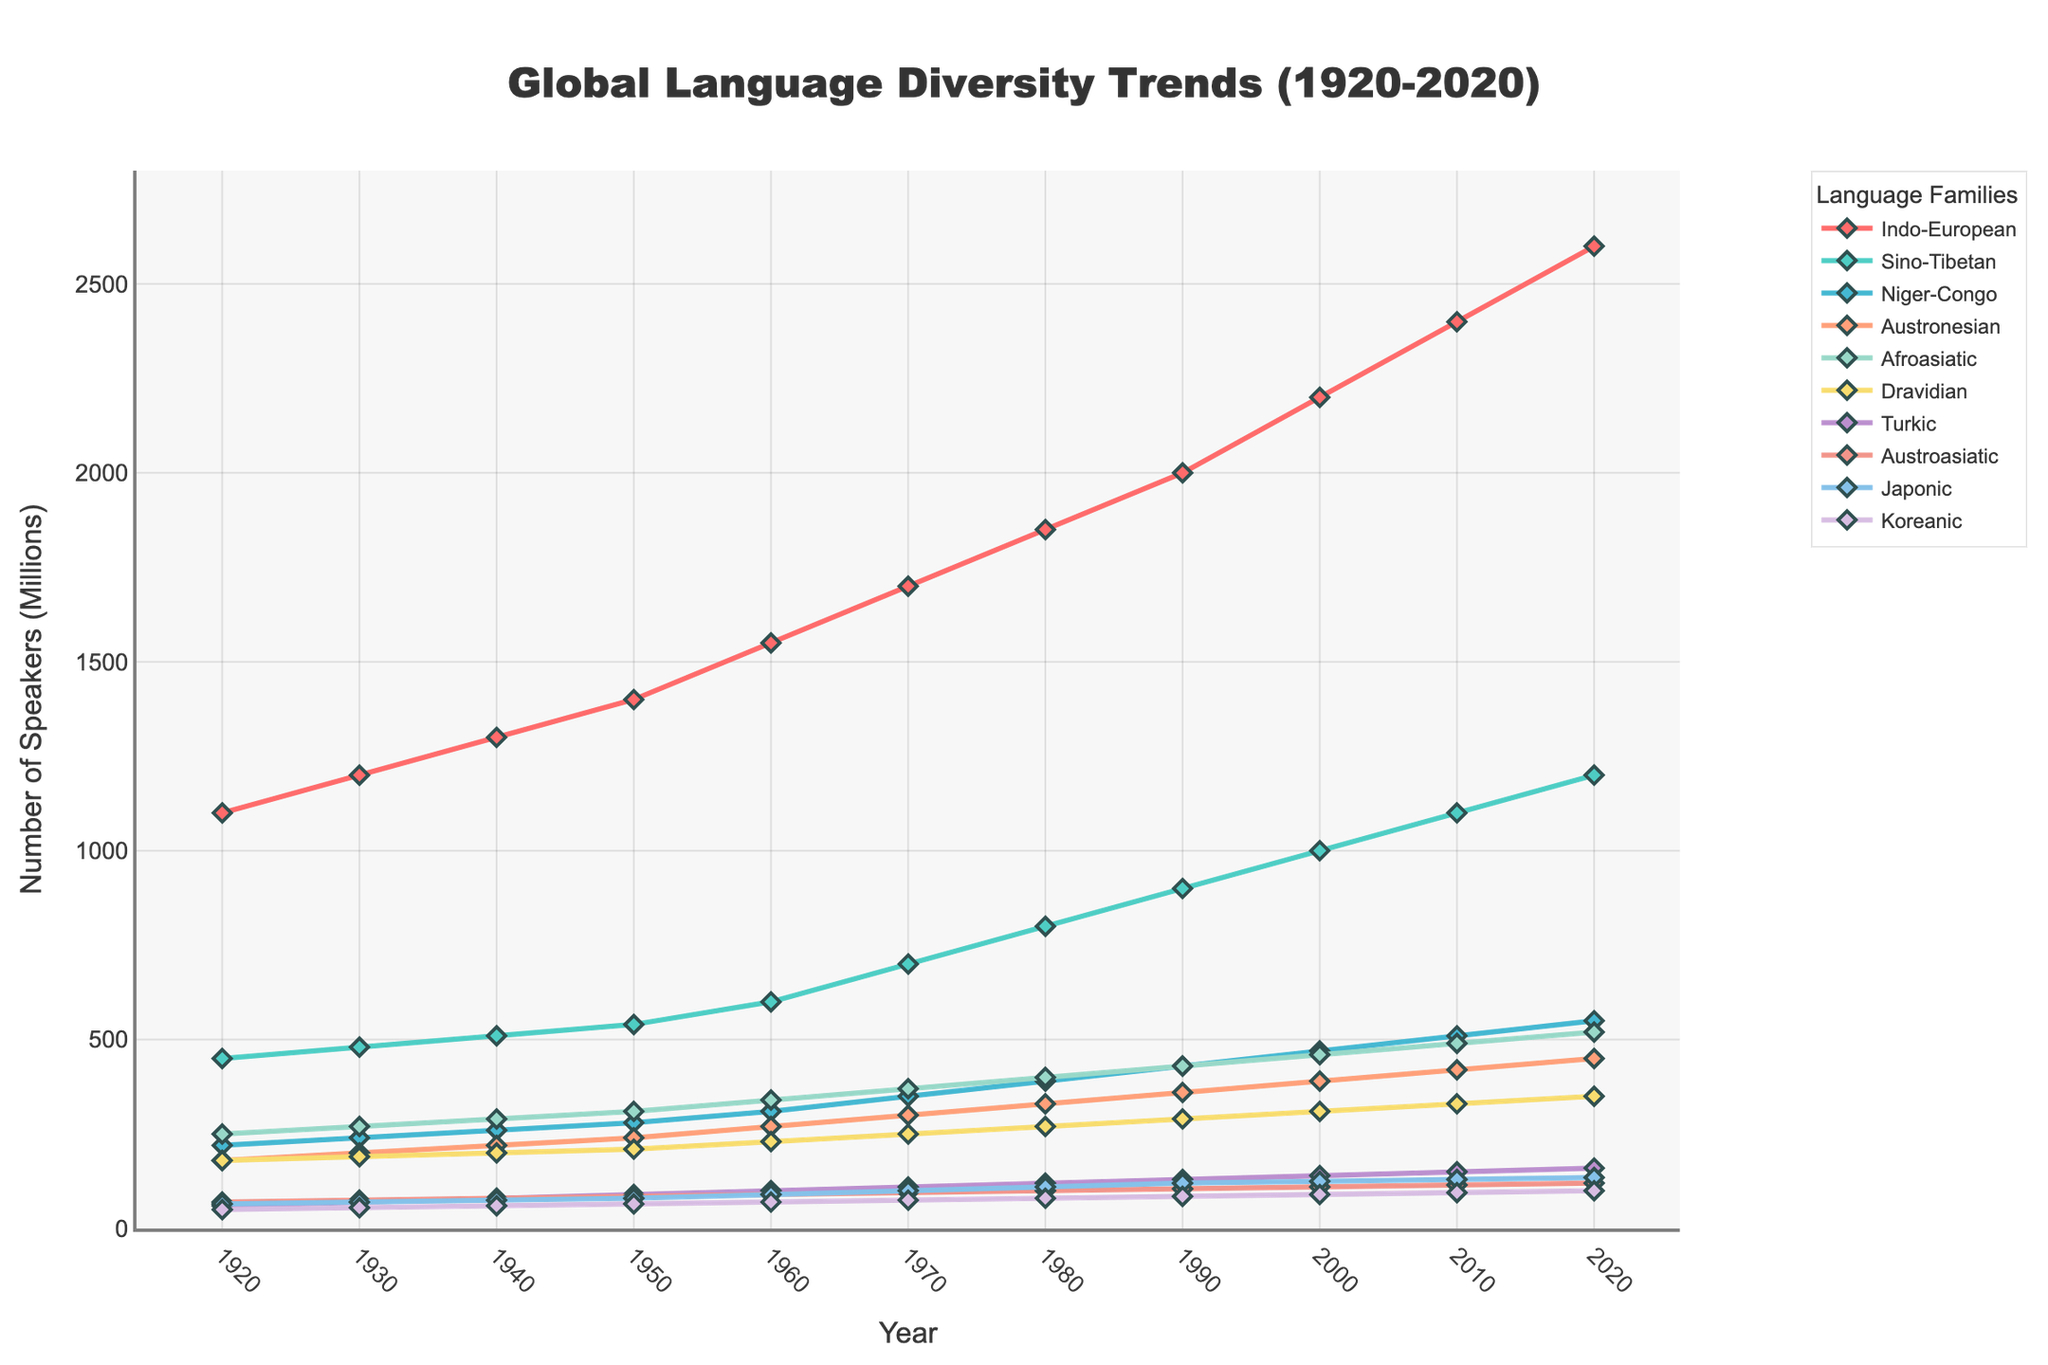What is the trend in the number of speakers for the Sino-Tibetan language family from 1920 to 2020? The number of speakers for the Sino-Tibetan language family shows a steady increase over the timeline, starting at 450 million in 1920 and reaching 1200 million in 2020.
Answer: Steady increase Which language family had the most significant growth in the number of speakers over the past century? To find this, calculate the difference in the number of speakers between 2020 and 1920 for each language family. The Indo-European family increased from 1100 million to 2600 million speakers, a growth of 1500 million, which is the largest.
Answer: Indo-European Compare the number of speakers for the Niger-Congo and the Austronesian language families in 1990. Which one had more speakers? In 1990, the Niger-Congo family had 430 million speakers, while the Austronesian family had 360 million speakers. Thus, the Niger-Congo family had more.
Answer: Niger-Congo What was the average number of speakers for the Afroasiatic language family every decade from 1960 to 2020? Sum the numbers for the Afroasiatic family from 1960 (340 million), 1970 (370 million), 1980 (400 million), 1990 (430 million), 2000 (460 million), 2010 (490 million), and 2020 (520 million). Then divide by 7 (340 + 370 + 400 + 430 + 460 + 490 + 520) / 7 = 430.
Answer: 430 million By how many millions did the number of speakers for the Dravidian language family change from 1920 to 2020? The difference in the number of speakers for the Dravidian family between 1920 and 2020 is 350 million - 180 million. This equals 170 million.
Answer: 170 million Which language family had the smallest relative increase in the number of speakers over the past century? Calculate the relative increase for each language family. The Koreanic family increased from 50 million to 100 million, doubling over the century, which is the smallest relative increase compared to others.
Answer: Koreanic What is the difference in the number of speakers between the Turkic and Japonic language families in 1970? In 1970, the Turkic family had 110 million speakers, and the Japonic family had 100 million speakers. So the difference is 10 million.
Answer: 10 million What's the pattern observed in the visual markers for the Austronesian language family? The visual markers for the Austronesian family are consistently orange diamonds with lines connecting them, indicating consistency in style across the decades.
Answer: Orange diamonds 